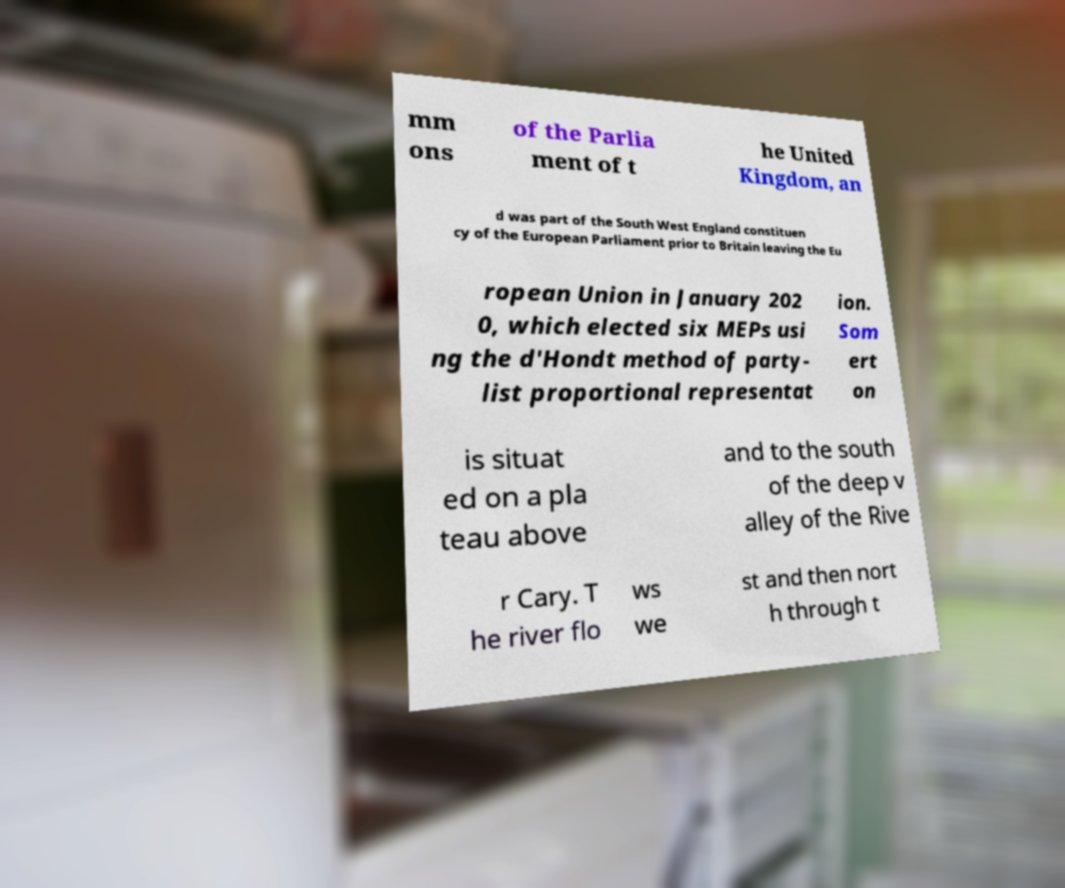There's text embedded in this image that I need extracted. Can you transcribe it verbatim? mm ons of the Parlia ment of t he United Kingdom, an d was part of the South West England constituen cy of the European Parliament prior to Britain leaving the Eu ropean Union in January 202 0, which elected six MEPs usi ng the d'Hondt method of party- list proportional representat ion. Som ert on is situat ed on a pla teau above and to the south of the deep v alley of the Rive r Cary. T he river flo ws we st and then nort h through t 